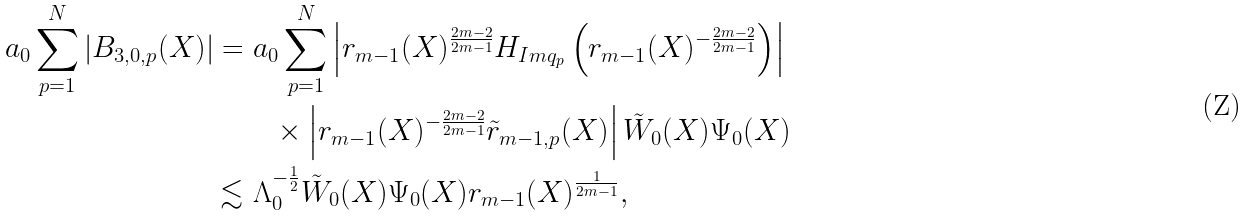<formula> <loc_0><loc_0><loc_500><loc_500>a _ { 0 } \sum _ { p = 1 } ^ { N } | B _ { 3 , 0 , p } ( X ) | = & \ a _ { 0 } \sum _ { p = 1 } ^ { N } \left | r _ { m - 1 } ( X ) ^ { \frac { 2 m - 2 } { 2 m - 1 } } H _ { I m q _ { p } } \left ( r _ { m - 1 } ( X ) ^ { - \frac { 2 m - 2 } { 2 m - 1 } } \right ) \right | \\ & \quad \times \left | r _ { m - 1 } ( X ) ^ { - \frac { 2 m - 2 } { 2 m - 1 } } \tilde { r } _ { m - 1 , p } ( X ) \right | \tilde { W } _ { 0 } ( X ) \Psi _ { 0 } ( X ) \\ \lesssim & \ \Lambda _ { 0 } ^ { - \frac { 1 } { 2 } } \tilde { W } _ { 0 } ( X ) \Psi _ { 0 } ( X ) r _ { m - 1 } ( X ) ^ { \frac { 1 } { 2 m - 1 } } ,</formula> 